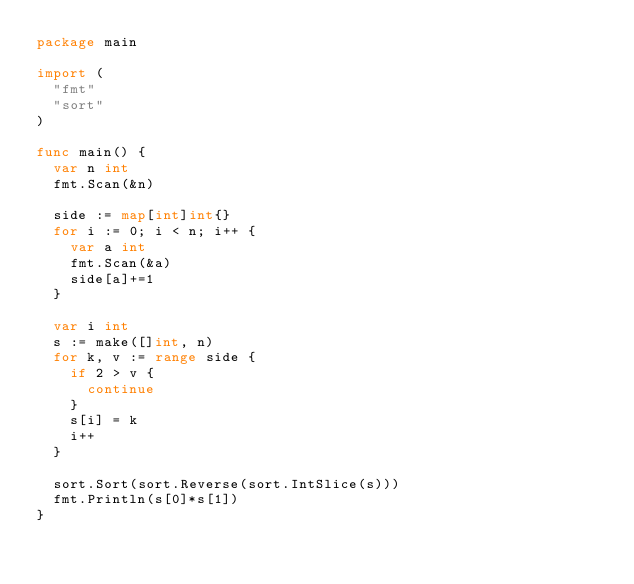Convert code to text. <code><loc_0><loc_0><loc_500><loc_500><_Go_>package main

import (
	"fmt"
	"sort"
)

func main() {
	var n int
	fmt.Scan(&n)

	side := map[int]int{}
	for i := 0; i < n; i++ {
		var a int
		fmt.Scan(&a)
		side[a]+=1
	}	

	var i int
	s := make([]int, n)
	for k, v := range side {
		if 2 > v {
			continue
		}
		s[i] = k
		i++
	}

	sort.Sort(sort.Reverse(sort.IntSlice(s)))
	fmt.Println(s[0]*s[1])
}</code> 